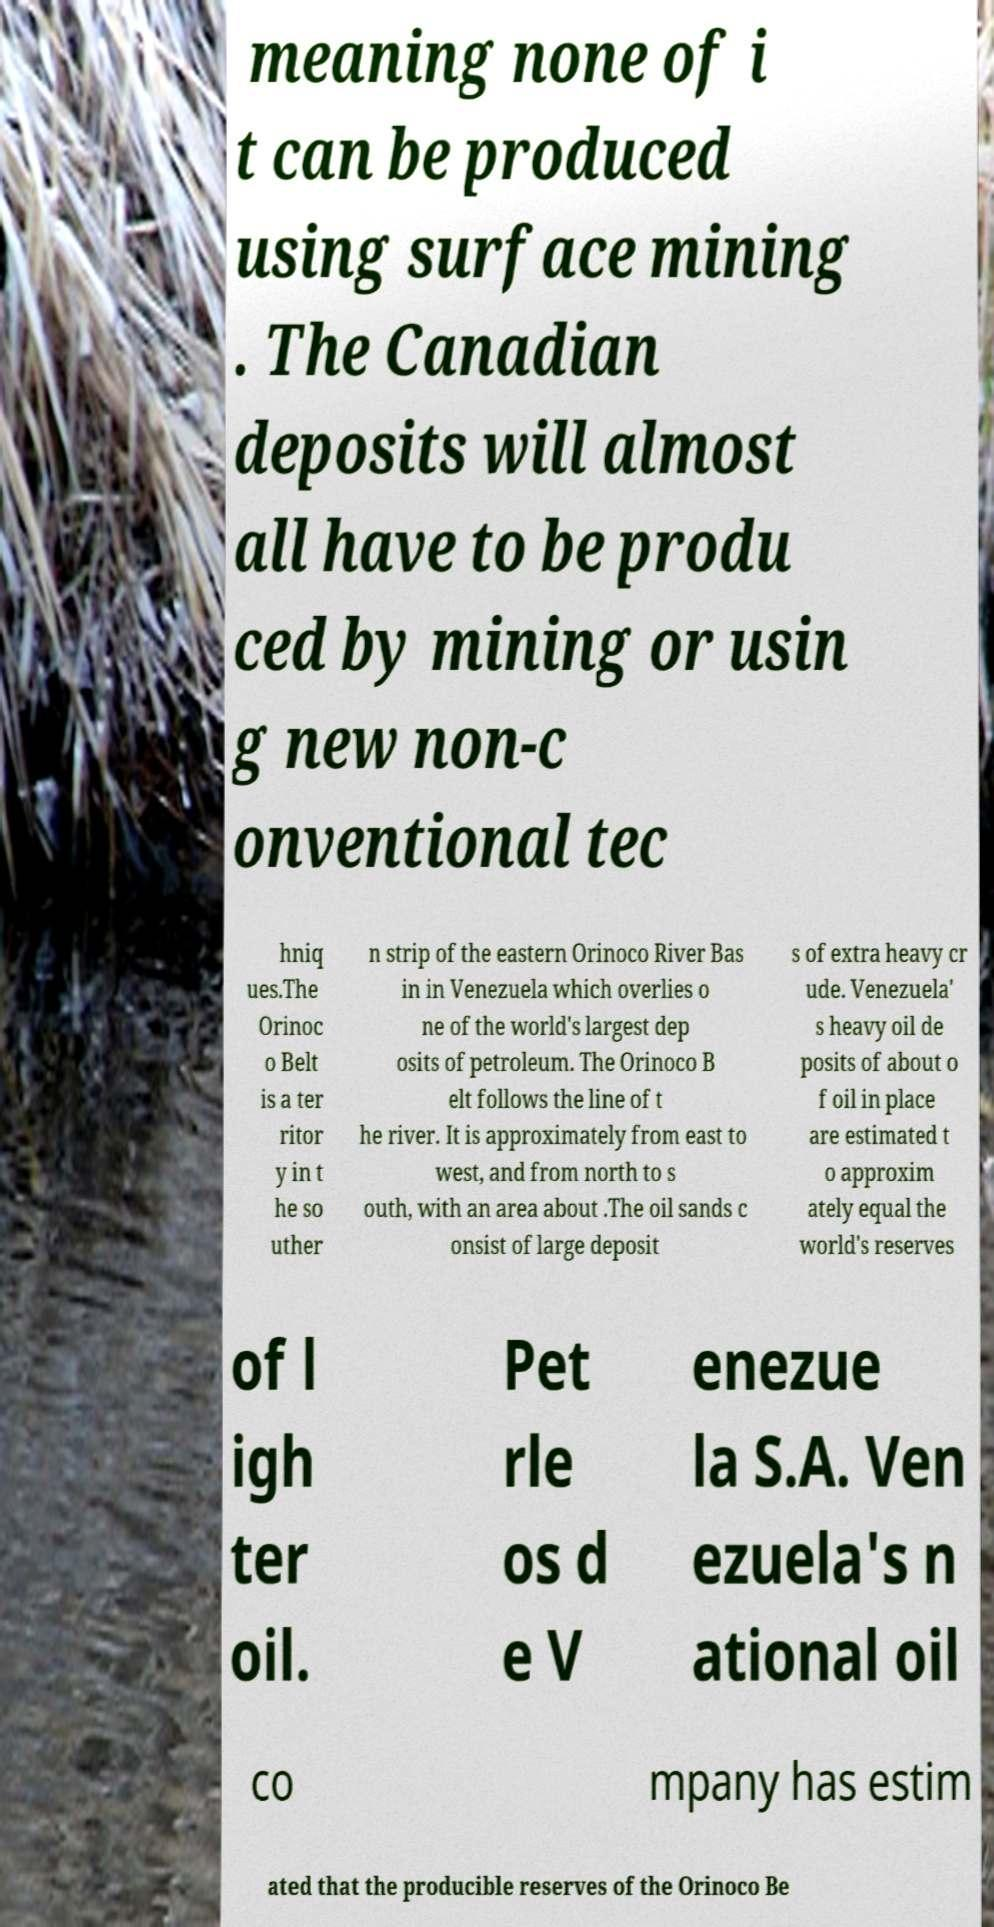Please identify and transcribe the text found in this image. meaning none of i t can be produced using surface mining . The Canadian deposits will almost all have to be produ ced by mining or usin g new non-c onventional tec hniq ues.The Orinoc o Belt is a ter ritor y in t he so uther n strip of the eastern Orinoco River Bas in in Venezuela which overlies o ne of the world's largest dep osits of petroleum. The Orinoco B elt follows the line of t he river. It is approximately from east to west, and from north to s outh, with an area about .The oil sands c onsist of large deposit s of extra heavy cr ude. Venezuela' s heavy oil de posits of about o f oil in place are estimated t o approxim ately equal the world's reserves of l igh ter oil. Pet rle os d e V enezue la S.A. Ven ezuela's n ational oil co mpany has estim ated that the producible reserves of the Orinoco Be 